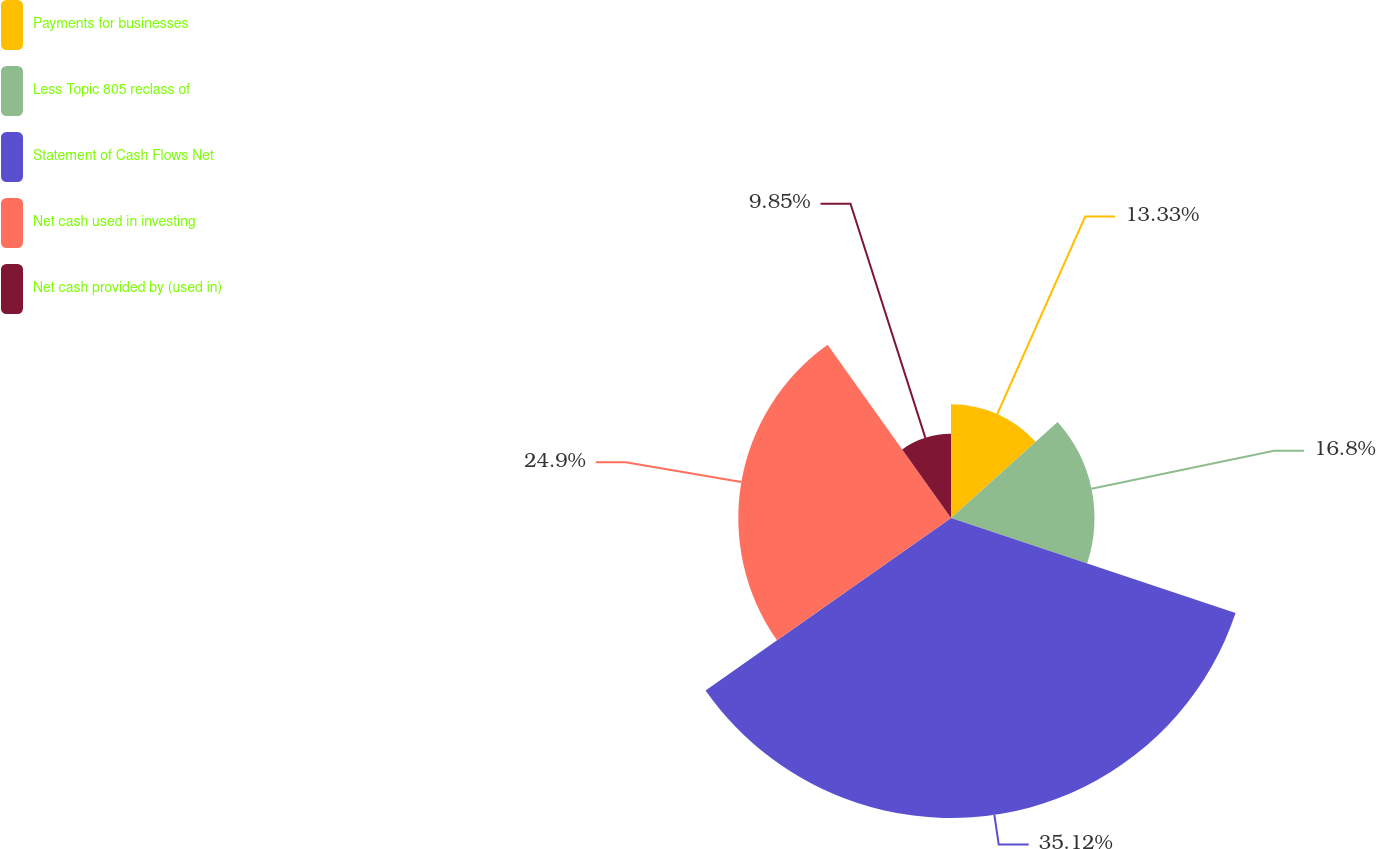Convert chart to OTSL. <chart><loc_0><loc_0><loc_500><loc_500><pie_chart><fcel>Payments for businesses<fcel>Less Topic 805 reclass of<fcel>Statement of Cash Flows Net<fcel>Net cash used in investing<fcel>Net cash provided by (used in)<nl><fcel>13.33%<fcel>16.8%<fcel>35.12%<fcel>24.9%<fcel>9.85%<nl></chart> 